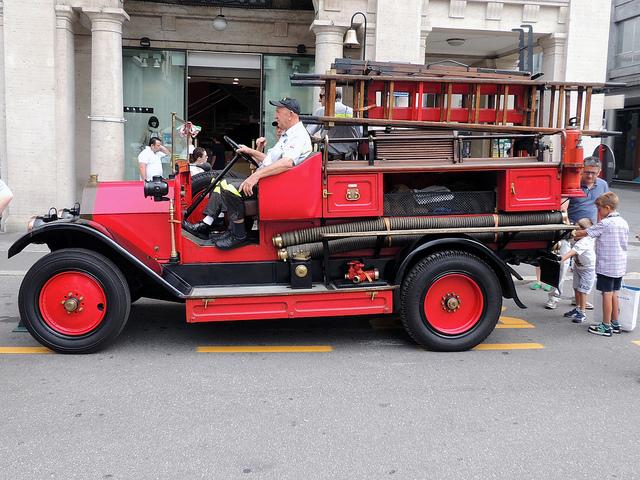What sort of dog would complete this picture?
Short answer required. Dalmatian. Is the ladder tall enough to reach the highest pillar visible in the picture?
Write a very short answer. Yes. Is anyone driving the truck?
Quick response, please. Yes. What kind of truck?
Give a very brief answer. Fire. 